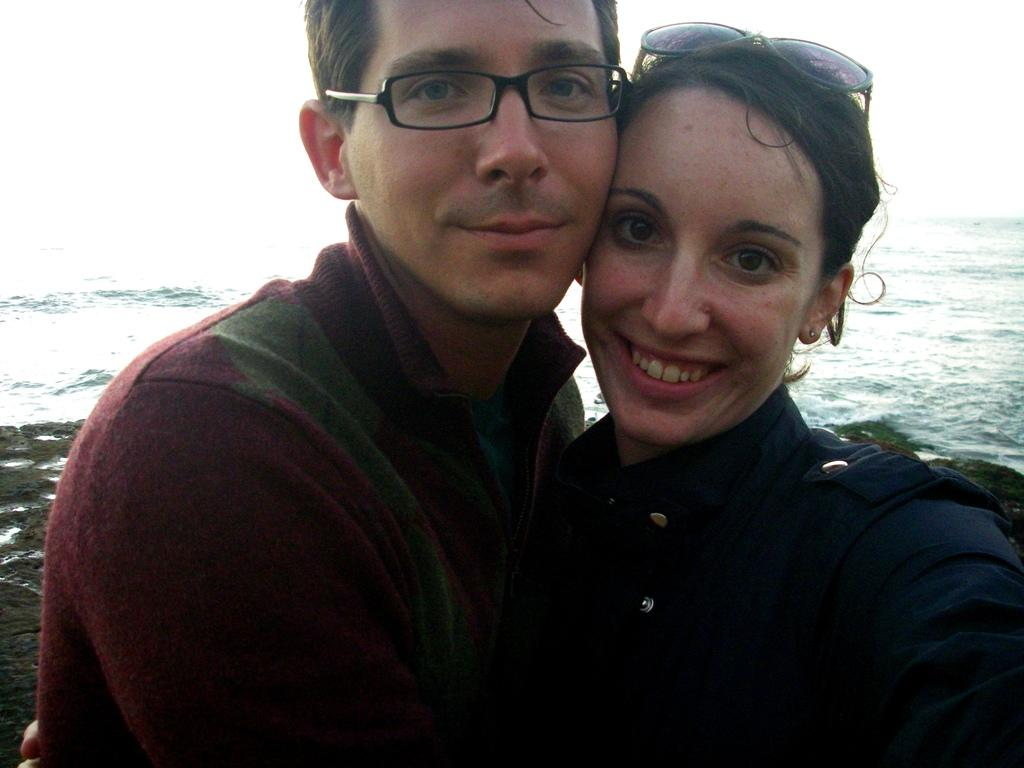How many people are in the image? There are two persons standing in the center of the image. What are the expressions on their faces? The persons are smiling. What can be seen in the background of the image? There is water visible in the background of the image. What type of bun is the grandmother holding in the image? There is no grandmother or bun present in the image. What kind of truck can be seen driving through the water in the background? There is no truck visible in the image; only water is present in the background. 